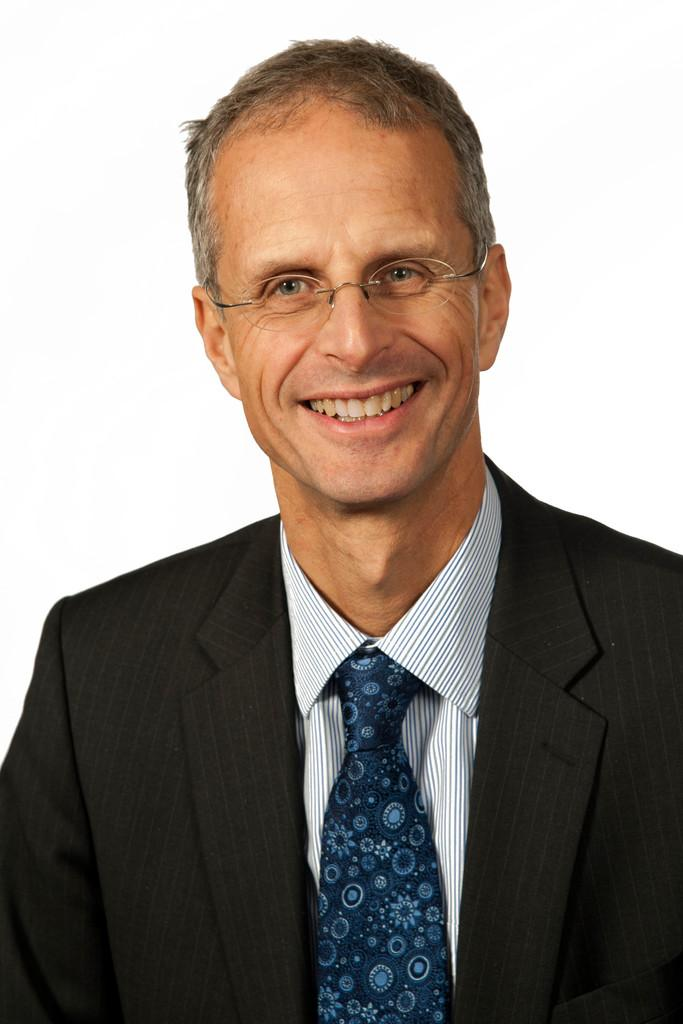What can be seen in the image? There is a person in the image. How is the person's facial expression? The person is smiling. What accessory is the person wearing? The person is wearing spectacles. What color is the background of the image? The background of the image is white. What type of kite is the person holding in the image? There is no kite present in the image; the person is not holding any object. 